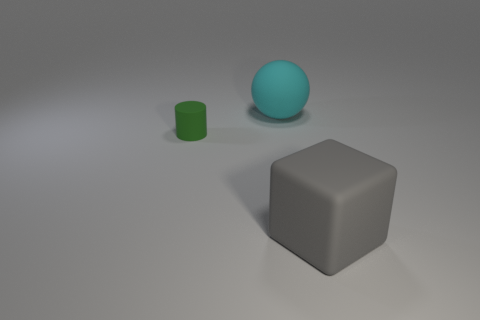Can you describe the shapes of the objects shown in the image? Sure, there are three geometric shapes in the image: a sphere, which is a round object shaped like a ball; a cylinder, which is a tube with circular ends; and a cube, which is a six-sided box-shaped object where all faces are squares and all edges are of equal length. 